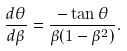<formula> <loc_0><loc_0><loc_500><loc_500>\frac { d \theta } { d \beta } = \frac { - \tan \theta } { \beta ( 1 - \beta ^ { 2 } ) } .</formula> 